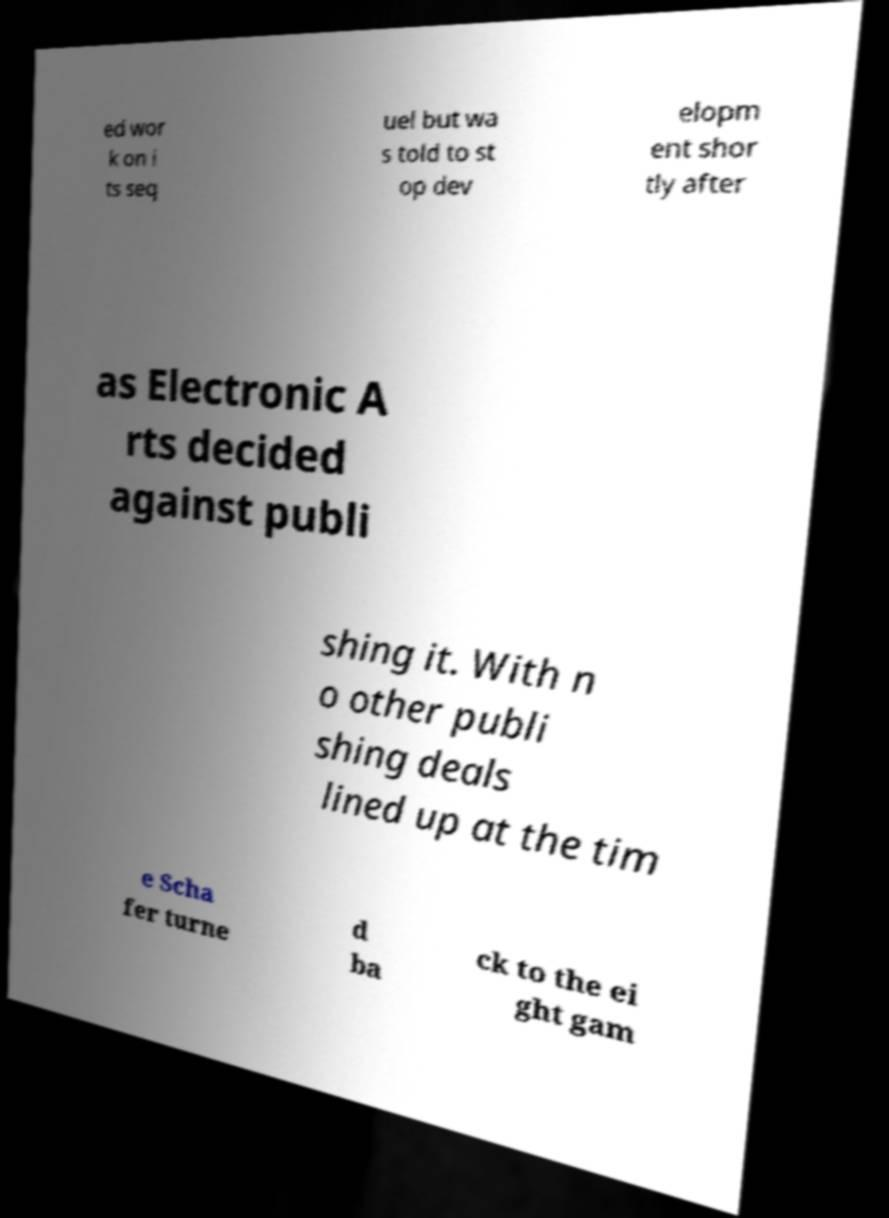Could you extract and type out the text from this image? ed wor k on i ts seq uel but wa s told to st op dev elopm ent shor tly after as Electronic A rts decided against publi shing it. With n o other publi shing deals lined up at the tim e Scha fer turne d ba ck to the ei ght gam 